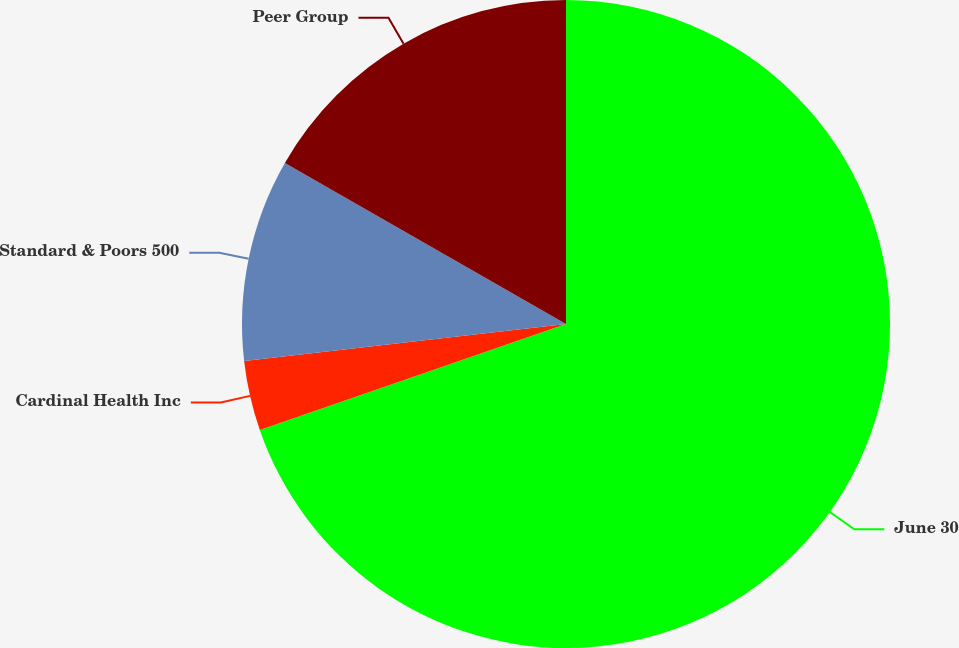Convert chart to OTSL. <chart><loc_0><loc_0><loc_500><loc_500><pie_chart><fcel>June 30<fcel>Cardinal Health Inc<fcel>Standard & Poors 500<fcel>Peer Group<nl><fcel>69.7%<fcel>3.48%<fcel>10.1%<fcel>16.72%<nl></chart> 